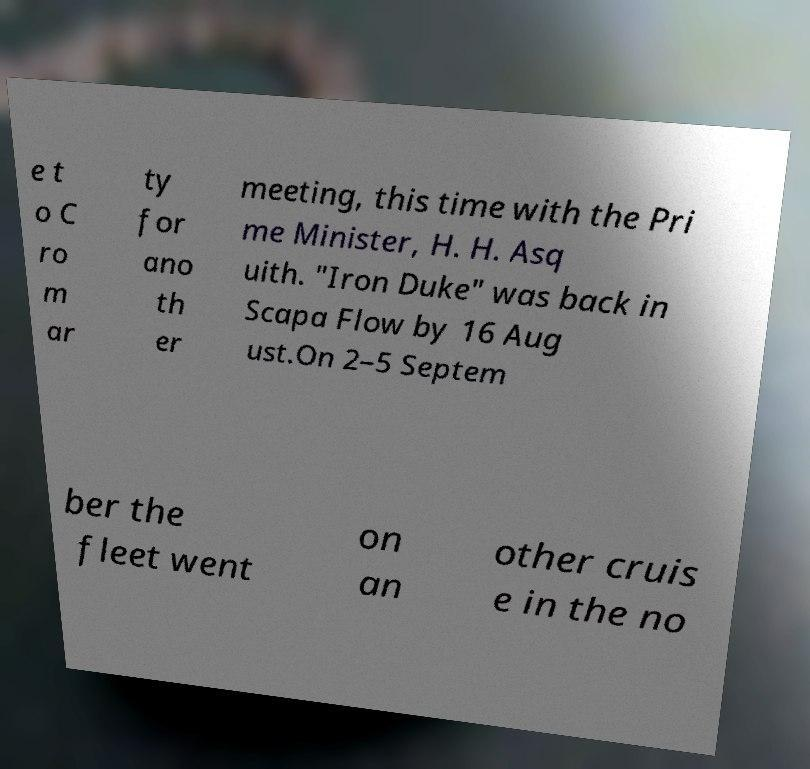Please identify and transcribe the text found in this image. e t o C ro m ar ty for ano th er meeting, this time with the Pri me Minister, H. H. Asq uith. "Iron Duke" was back in Scapa Flow by 16 Aug ust.On 2–5 Septem ber the fleet went on an other cruis e in the no 